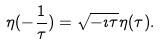Convert formula to latex. <formula><loc_0><loc_0><loc_500><loc_500>\eta ( - \frac { 1 } { \tau } ) = \sqrt { - \imath \tau } \eta ( \tau ) .</formula> 